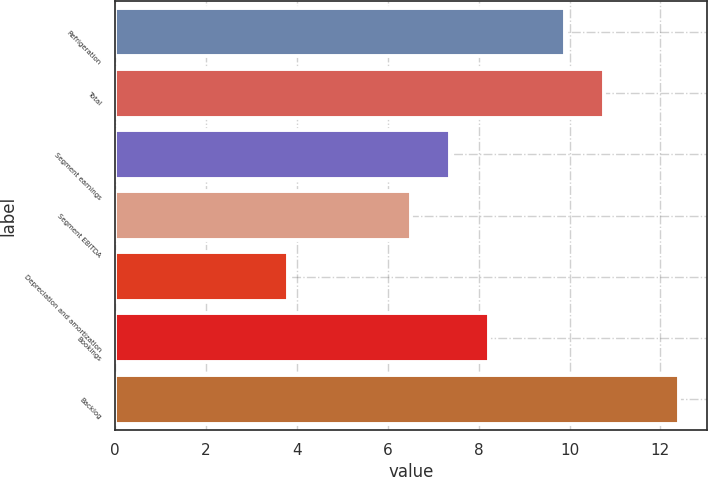Convert chart to OTSL. <chart><loc_0><loc_0><loc_500><loc_500><bar_chart><fcel>Refrigeration<fcel>Total<fcel>Segment earnings<fcel>Segment EBITDA<fcel>Depreciation and amortization<fcel>Bookings<fcel>Backlog<nl><fcel>9.9<fcel>10.76<fcel>7.36<fcel>6.5<fcel>3.8<fcel>8.22<fcel>12.4<nl></chart> 